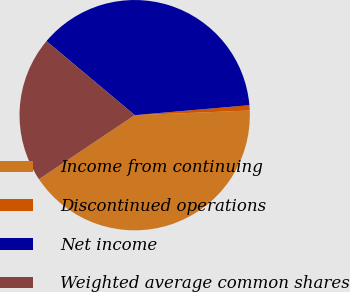<chart> <loc_0><loc_0><loc_500><loc_500><pie_chart><fcel>Income from continuing<fcel>Discontinued operations<fcel>Net income<fcel>Weighted average common shares<nl><fcel>41.26%<fcel>0.74%<fcel>37.51%<fcel>20.49%<nl></chart> 